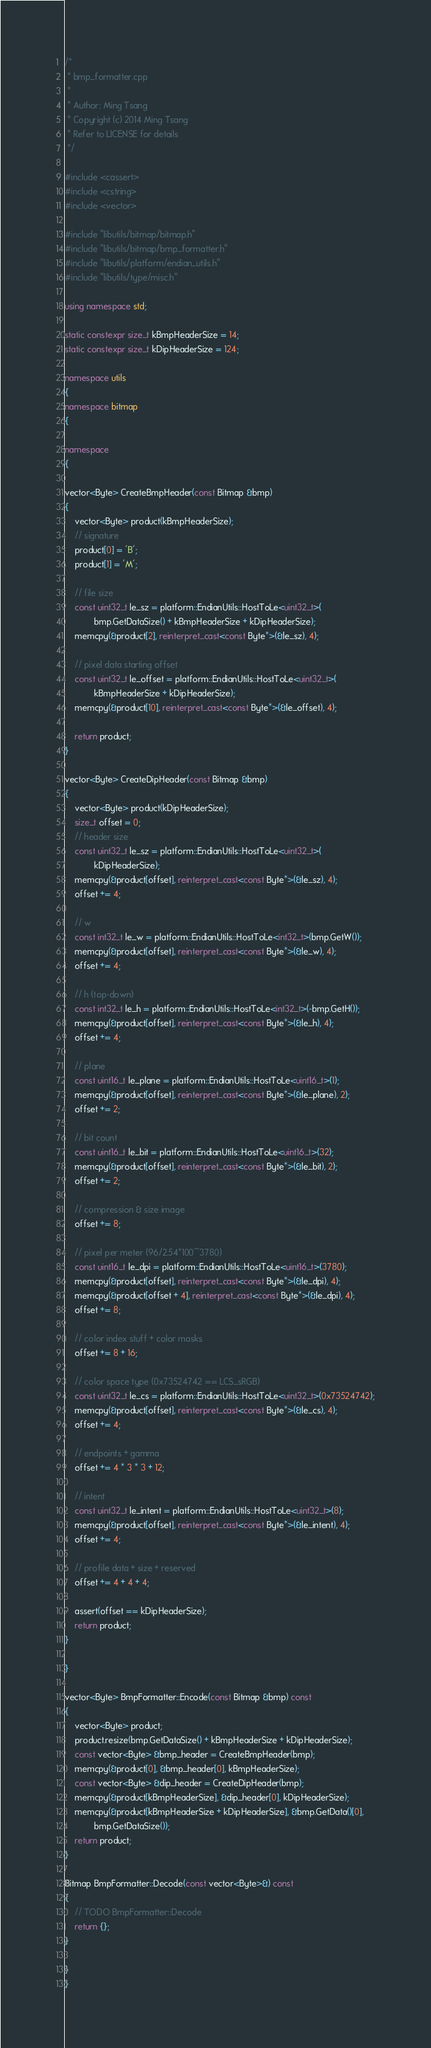Convert code to text. <code><loc_0><loc_0><loc_500><loc_500><_C++_>/*
 * bmp_formatter.cpp
 *
 * Author: Ming Tsang
 * Copyright (c) 2014 Ming Tsang
 * Refer to LICENSE for details
 */

#include <cassert>
#include <cstring>
#include <vector>

#include "libutils/bitmap/bitmap.h"
#include "libutils/bitmap/bmp_formatter.h"
#include "libutils/platform/endian_utils.h"
#include "libutils/type/misc.h"

using namespace std;

static constexpr size_t kBmpHeaderSize = 14;
static constexpr size_t kDipHeaderSize = 124;

namespace utils
{
namespace bitmap
{

namespace
{

vector<Byte> CreateBmpHeader(const Bitmap &bmp)
{
	vector<Byte> product(kBmpHeaderSize);
	// signature
	product[0] = 'B';
	product[1] = 'M';

	// file size
	const uint32_t le_sz = platform::EndianUtils::HostToLe<uint32_t>(
			bmp.GetDataSize() + kBmpHeaderSize + kDipHeaderSize);
	memcpy(&product[2], reinterpret_cast<const Byte*>(&le_sz), 4);

	// pixel data starting offset
	const uint32_t le_offset = platform::EndianUtils::HostToLe<uint32_t>(
			kBmpHeaderSize + kDipHeaderSize);
	memcpy(&product[10], reinterpret_cast<const Byte*>(&le_offset), 4);

	return product;
}

vector<Byte> CreateDipHeader(const Bitmap &bmp)
{
	vector<Byte> product(kDipHeaderSize);
	size_t offset = 0;
	// header size
	const uint32_t le_sz = platform::EndianUtils::HostToLe<uint32_t>(
			kDipHeaderSize);
	memcpy(&product[offset], reinterpret_cast<const Byte*>(&le_sz), 4);
	offset += 4;

	// w
	const int32_t le_w = platform::EndianUtils::HostToLe<int32_t>(bmp.GetW());
	memcpy(&product[offset], reinterpret_cast<const Byte*>(&le_w), 4);
	offset += 4;

	// h (top-down)
	const int32_t le_h = platform::EndianUtils::HostToLe<int32_t>(-bmp.GetH());
	memcpy(&product[offset], reinterpret_cast<const Byte*>(&le_h), 4);
	offset += 4;

	// plane
	const uint16_t le_plane = platform::EndianUtils::HostToLe<uint16_t>(1);
	memcpy(&product[offset], reinterpret_cast<const Byte*>(&le_plane), 2);
	offset += 2;

	// bit count
	const uint16_t le_bit = platform::EndianUtils::HostToLe<uint16_t>(32);
	memcpy(&product[offset], reinterpret_cast<const Byte*>(&le_bit), 2);
	offset += 2;

	// compression & size image
	offset += 8;

	// pixel per meter (96/2.54*100~3780)
	const uint16_t le_dpi = platform::EndianUtils::HostToLe<uint16_t>(3780);
	memcpy(&product[offset], reinterpret_cast<const Byte*>(&le_dpi), 4);
	memcpy(&product[offset + 4], reinterpret_cast<const Byte*>(&le_dpi), 4);
	offset += 8;

	// color index stuff + color masks
	offset += 8 + 16;

	// color space type (0x73524742 == LCS_sRGB)
	const uint32_t le_cs = platform::EndianUtils::HostToLe<uint32_t>(0x73524742);
	memcpy(&product[offset], reinterpret_cast<const Byte*>(&le_cs), 4);
	offset += 4;

	// endpoints + gamma
	offset += 4 * 3 * 3 + 12;

	// intent
	const uint32_t le_intent = platform::EndianUtils::HostToLe<uint32_t>(8);
	memcpy(&product[offset], reinterpret_cast<const Byte*>(&le_intent), 4);
	offset += 4;

	// profile data + size + reserved
	offset += 4 + 4 + 4;

	assert(offset == kDipHeaderSize);
	return product;
}

}

vector<Byte> BmpFormatter::Encode(const Bitmap &bmp) const
{
	vector<Byte> product;
	product.resize(bmp.GetDataSize() + kBmpHeaderSize + kDipHeaderSize);
	const vector<Byte> &bmp_header = CreateBmpHeader(bmp);
	memcpy(&product[0], &bmp_header[0], kBmpHeaderSize);
	const vector<Byte> &dip_header = CreateDipHeader(bmp);
	memcpy(&product[kBmpHeaderSize], &dip_header[0], kDipHeaderSize);
	memcpy(&product[kBmpHeaderSize + kDipHeaderSize], &bmp.GetData()[0],
			bmp.GetDataSize());
	return product;
}

Bitmap BmpFormatter::Decode(const vector<Byte>&) const
{
	// TODO BmpFormatter::Decode
	return {};
}

}
}
</code> 